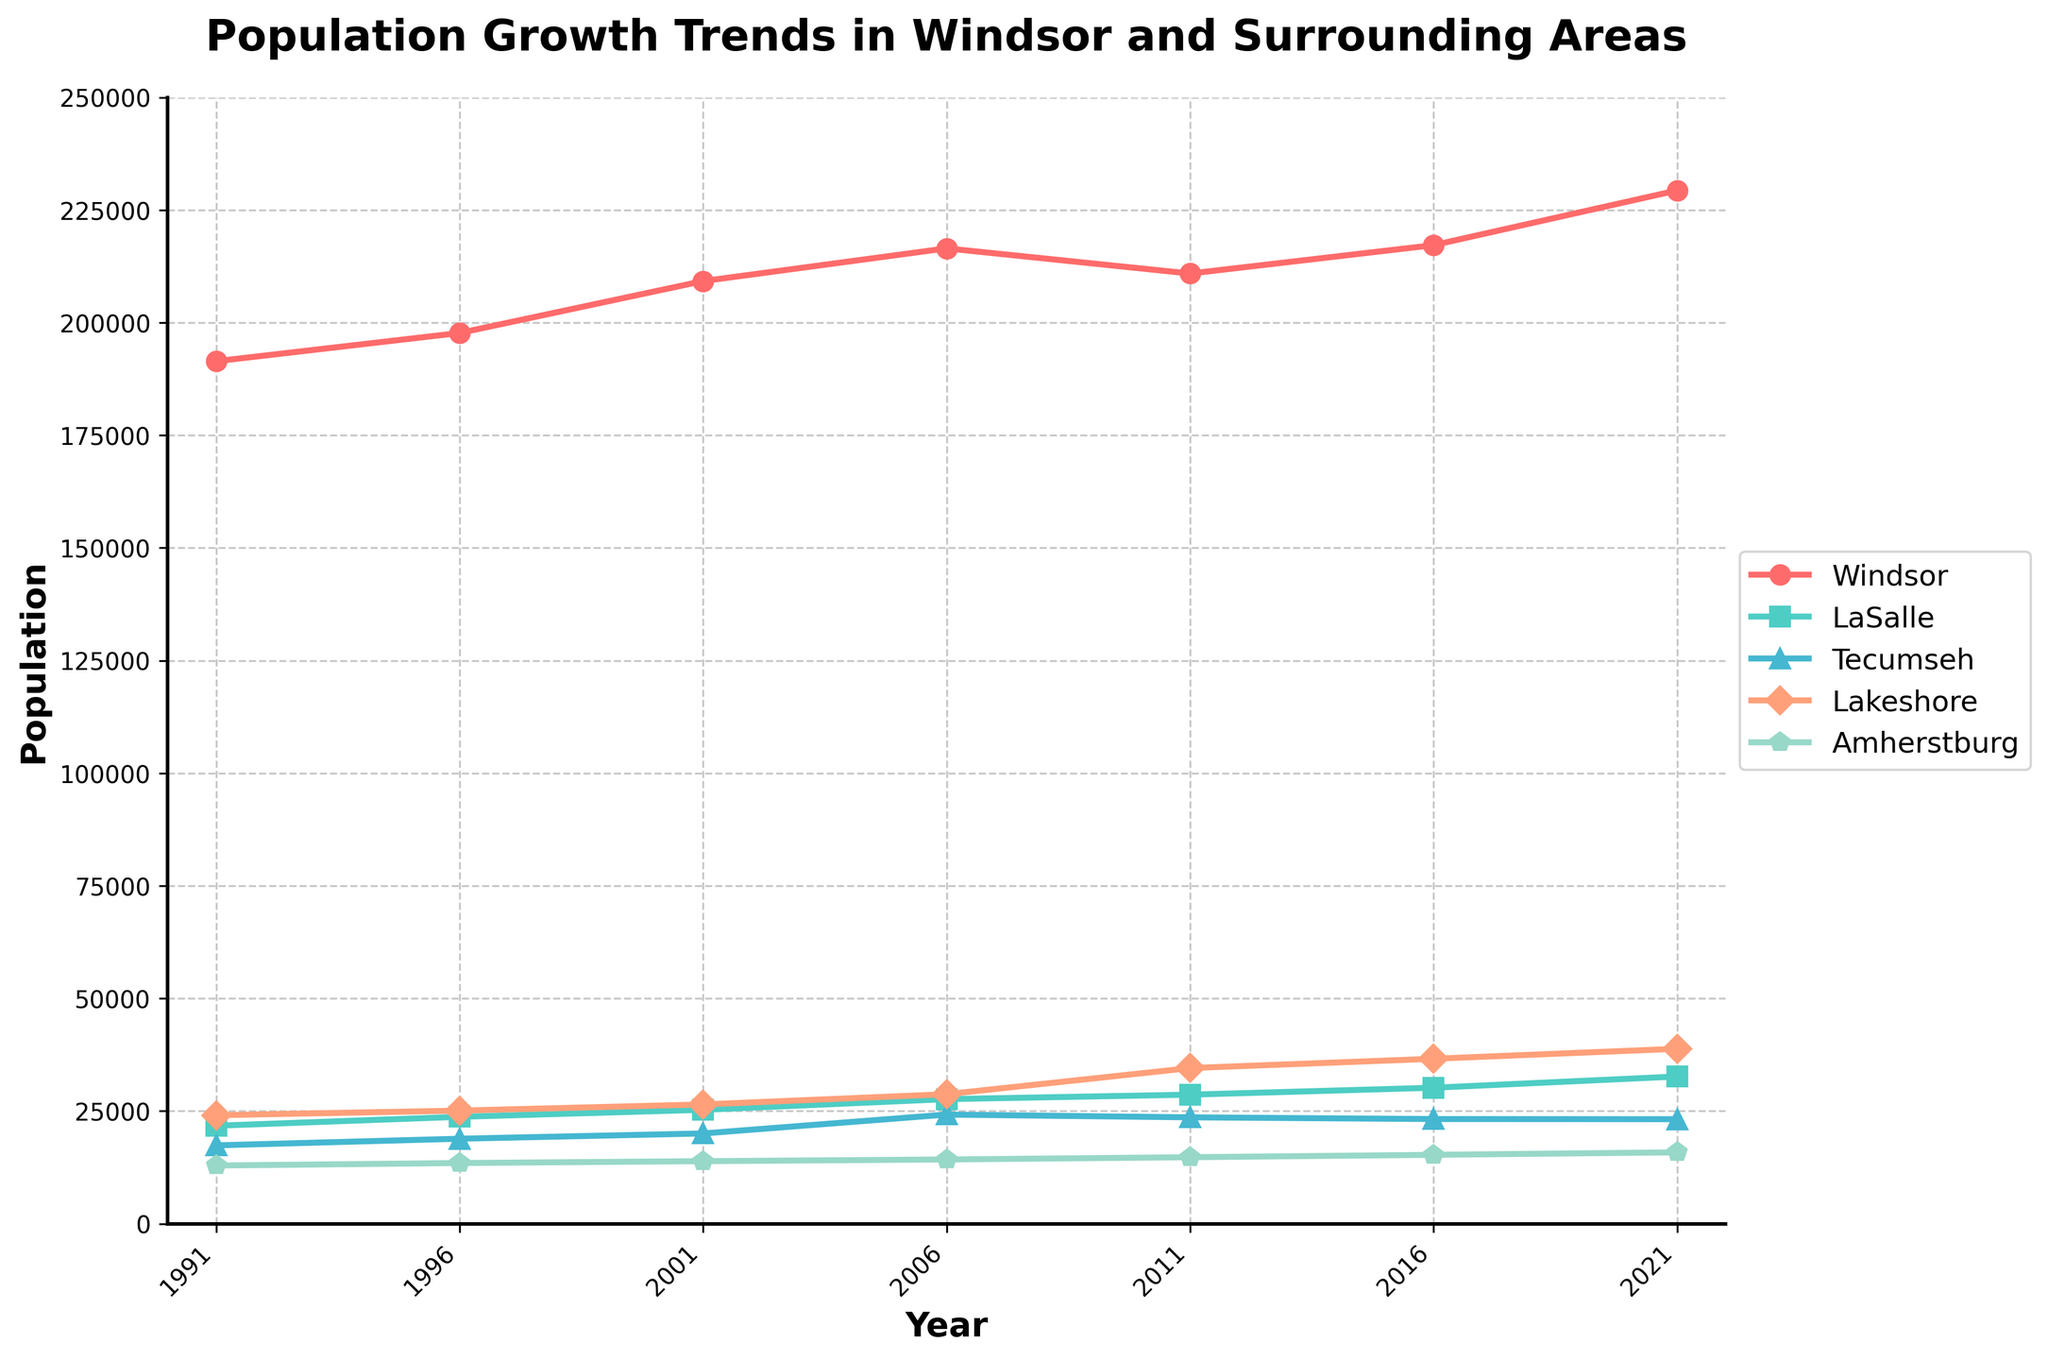What is the highest population value reached by Windsor over the last 30 years? By examining the line chart for Windsor, we see that the population reaches its peak value in 2021.
Answer: 229,325 Which area had the most significant population growth between 1991 and 2021? By comparing the population values from 1991 and 2021 for all areas, the highest increase is seen in Lakeshore. Difference calculations: Windsor = 229,325 - 191,435 = 37,890, LaSalle = 32,673 - 21,748 = 10,925, Tecumseh = 23,200 - 17,389 = 5,811, Lakeshore = 38,829 - 24,082 = 14,747, Amherstburg = 15,845 - 12,915 = 2,930
Answer: Lakeshore Which year saw a population decrease for Windsor compared to the previous census year? Observing the Windsor line, the population decreases from 2006 to 2011.
Answer: 2011 How did the population of Amherstburg change from 1991 to 2021? By checking the starting and final points for Amherstburg, in 1991 the population was 12,915, and in 2021 it was 15,845. The change can be found as: 15,845 - 12,915 = 2,930
Answer: Increased by 2,930 In which year did Windsor have its smallest population in the last 30 years? The smallest point on Windsor’s line between 1991 and 2021 is in 2011.
Answer: 2011 Which area had the second-highest population in 2021? Looking at the final values for 2021, Windsor is the highest, and Lakeshore is the second, with 38,829.
Answer: Lakeshore Compare the population trends of LaSalle and Tecumseh over the past 30 years. Which area shows a higher average growth per decade? Calculate the differences per decade and average for both areas: LaSalle (1991-2021): 32,673 - 21,748 = 10,925, and average per decade = 10,925 / 3 = 3,642. Tecumseh (1991-2021): 23,200 - 17,389 = 5,811, and average per decade = 5,811 / 3 = 1,937. LaSalle has a higher average growth per decade.
Answer: LaSalle By how much did Lakeshore’s population increase between 2011 and 2021? Checking the values for Lakeshore in 2011 and 2021, the difference is 38,829 - 34,546 = 4,283
Answer: 4,283 Which area showed the most consistent growth trend over the last 30 years? Observing the smoothness of the lines, LaSalle shows the most consistent upward trend without any dips.
Answer: LaSalle Among Windsor, LaSalle, and Tecumseh, which area had the largest population percentage increase from 1991 to 2021? Percentage increase calculation: Windsor = (229,325 - 191,435) / 191,435 * 100 ≈ 19.8%; LaSalle = (32,673 - 21,748) / 21,748 * 100 ≈ 50.3%; Tecumseh = (23,200 - 17,389) / 17,389 * 100 ≈ 33.4%. LaSalle has the largest percentage increase.
Answer: LaSalle 